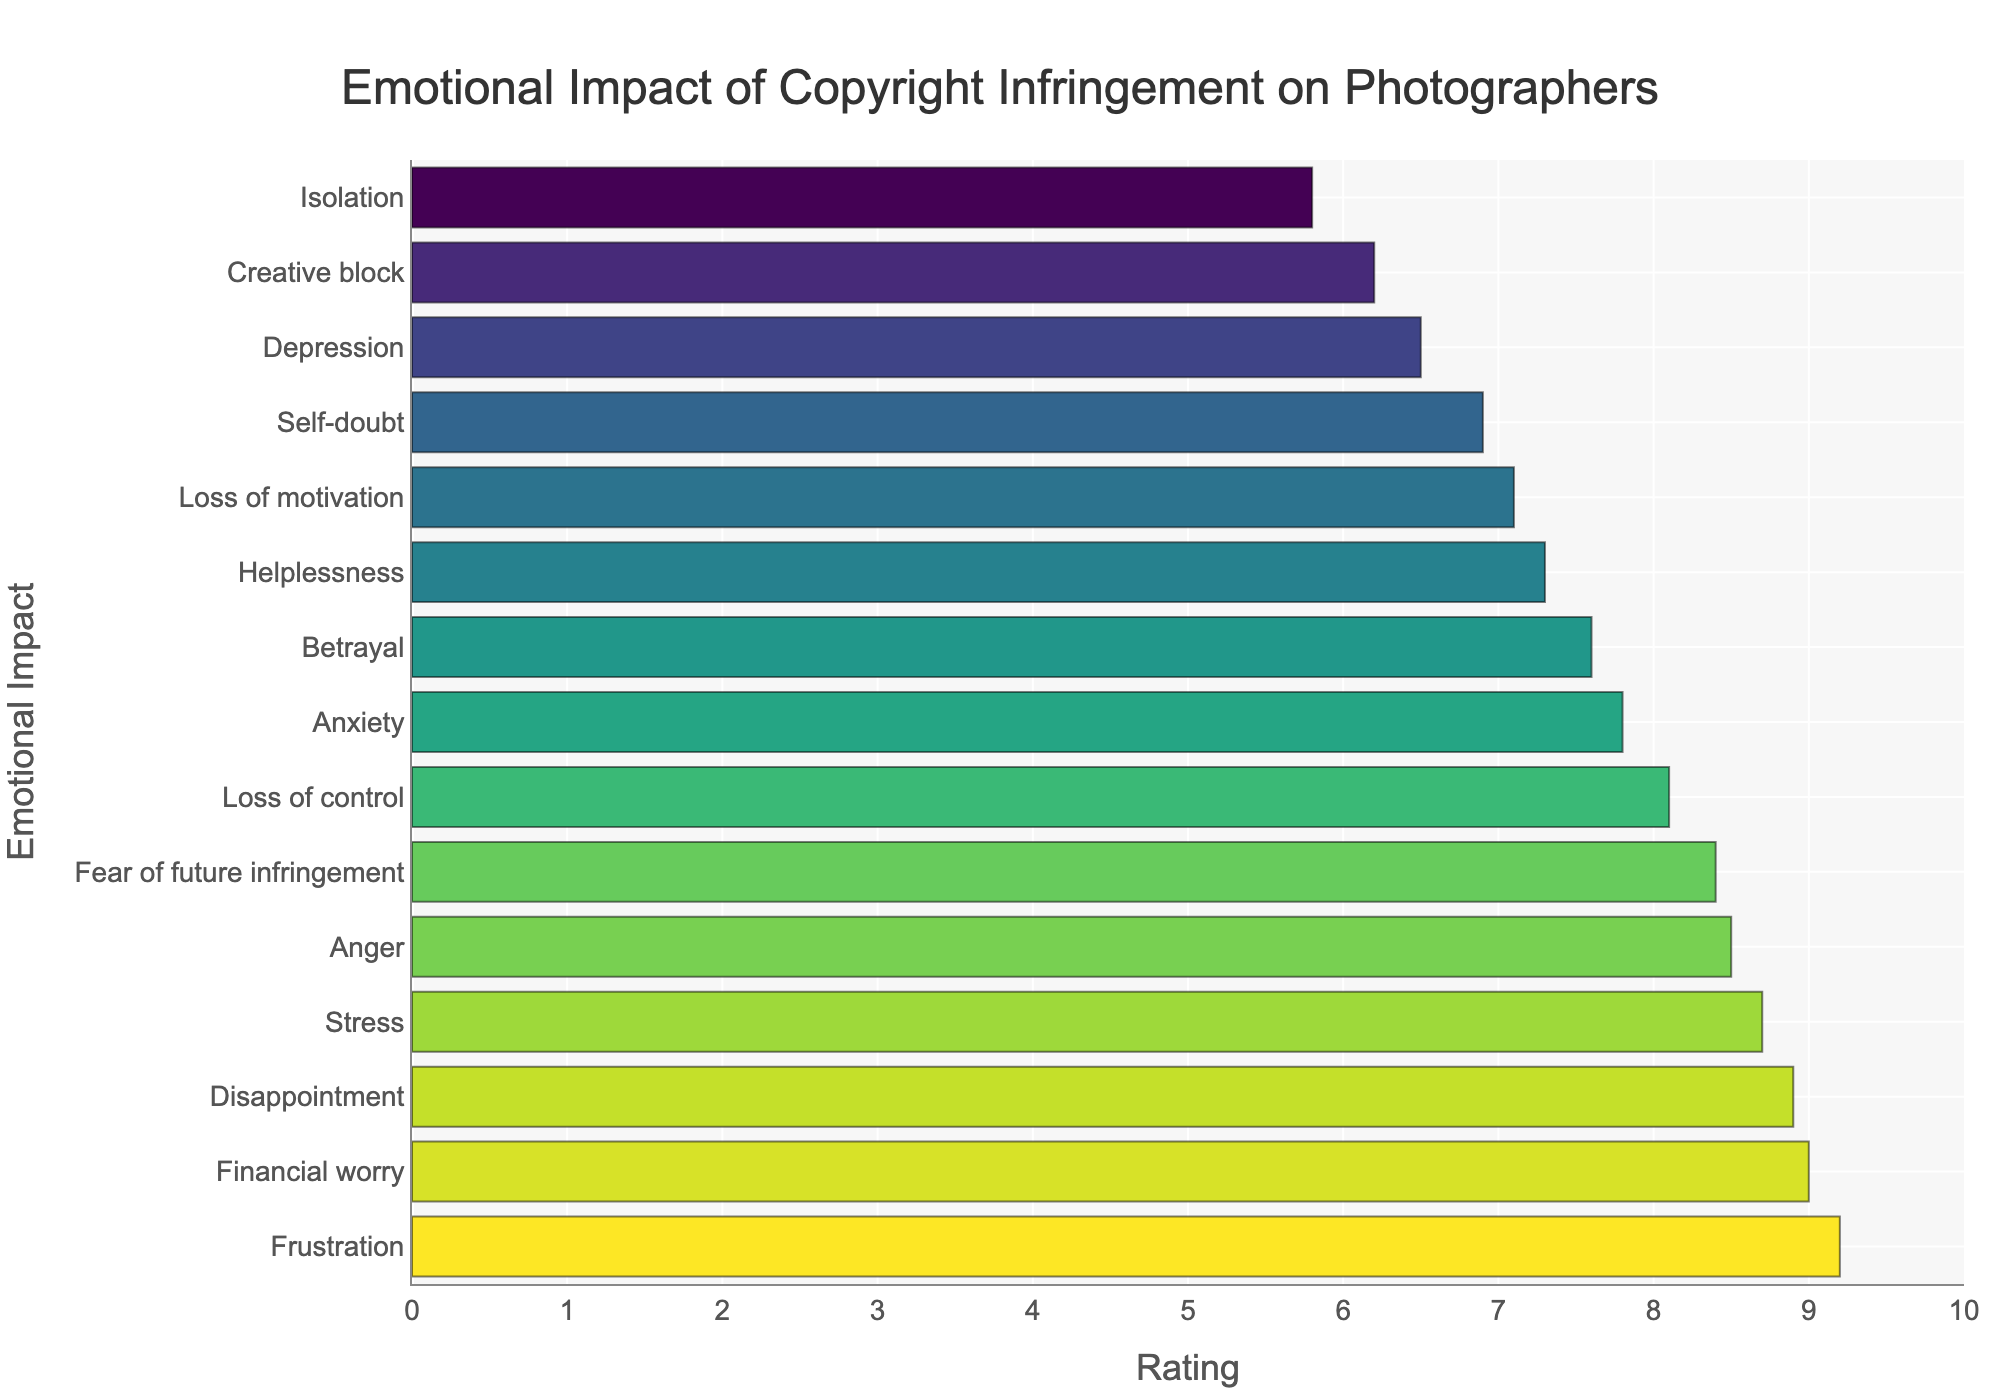What emotional impact has the highest rating? The emotional impact with the highest rating can be identified by looking at the topmost bar in the sorted horizontal bar chart. The topmost bar is labeled "Frustration," and its corresponding rating is 9.2.
Answer: Frustration What is the difference in rating between the highest and lowest rated emotional impacts? To find the difference between the highest and lowest ratings, identify the highest rating (Frustration, 9.2) and the lowest rating (Isolation, 5.8). Subtract the lowest rating from the highest rating: 9.2 - 5.8 = 3.4.
Answer: 3.4 Which emotional impact has a rating of 8.7? Locate the bar with a rating of 8.7 in the chart. The emotional impact labeled with this rating is "Stress."
Answer: Stress Which emotional impact has a higher rating, "Anger" or "Betrayal"? Compare the ratings of "Anger" and "Betrayal" on the chart. "Anger" has a rating of 8.5 and "Betrayal" has a rating of 7.6. Since 8.5 is greater than 7.6, "Anger" has a higher rating.
Answer: Anger What is the average rating of "Disappointment," "Helplessness," and "Fear of future infringement"? Calculate the average rating by summing the ratings of "Disappointment" (8.9), "Helplessness" (7.3), and "Fear of future infringement" (8.4), then dividing by 3. (8.9 + 7.3 + 8.4) / 3 = 24.6 / 3 = 8.2.
Answer: 8.2 How many emotional impacts have a rating greater than 8? Count the number of bars with ratings greater than 8. These emotional impacts are "Anger," "Frustration," "Disappointment," "Fear of future infringement," "Stress," and "Financial worry," totaling 6.
Answer: 6 Which emotional impact appears directly below "Self-doubt" in the chart? Locate "Self-doubt" in the chart and identify the emotional impact immediately below it. "Loss of motivation" appears directly below "Self-doubt."
Answer: Loss of motivation Is "Creative block" rated higher or lower than "Depression"? Compare the ratings of "Creative block" (6.2) and "Depression" (6.5) on the chart. Since 6.2 is less than 6.5, "Creative block" is rated lower than "Depression."
Answer: Lower What is the combined rating of "Financial worry" and "Loss of control"? Add the ratings of "Financial worry" (9.0) and "Loss of control" (8.1). 9.0 + 8.1 = 17.1.
Answer: 17.1 What are the most and least frequent colors used in the bars? Identify the colors used in the bars visually. The most frequent color appears to be a shade of green, while the least frequent color is yellow, indicating the highest and lowest values respectively in green-to-yellow color mapping.
Answer: Green and Yellow 